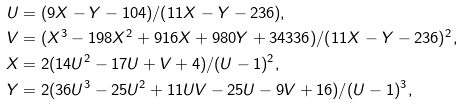Convert formula to latex. <formula><loc_0><loc_0><loc_500><loc_500>U & = ( 9 X - Y - 1 0 4 ) / ( 1 1 X - Y - 2 3 6 ) , \\ V & = ( X ^ { 3 } - 1 9 8 X ^ { 2 } + 9 1 6 X + 9 8 0 Y + 3 4 3 3 6 ) / ( 1 1 X - Y - 2 3 6 ) ^ { 2 } , \\ X & = 2 ( 1 4 U ^ { 2 } - 1 7 U + V + 4 ) / ( U - 1 ) ^ { 2 } , \\ Y & = 2 ( 3 6 U ^ { 3 } - 2 5 U ^ { 2 } + 1 1 U V - 2 5 U - 9 V + 1 6 ) / ( U - 1 ) ^ { 3 } ,</formula> 